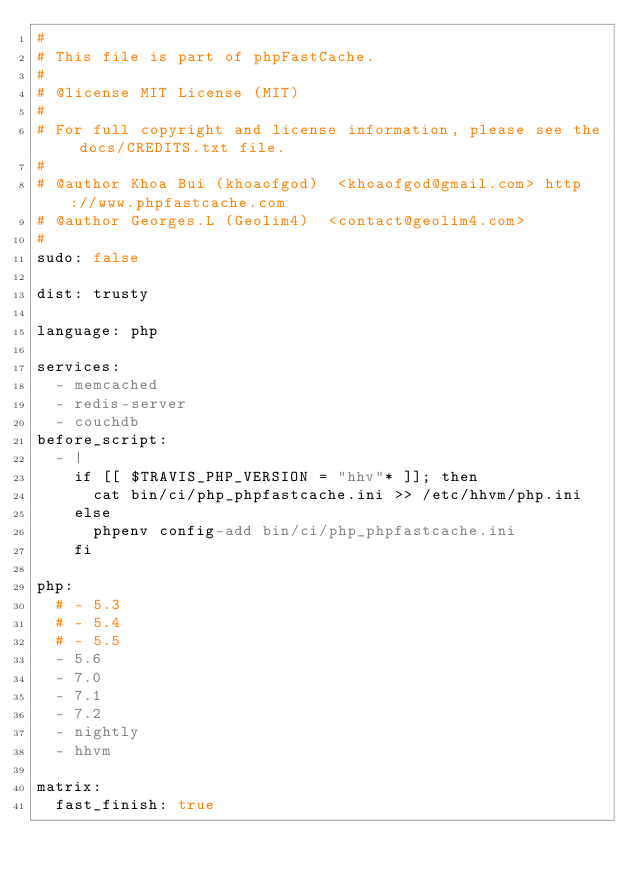Convert code to text. <code><loc_0><loc_0><loc_500><loc_500><_YAML_>#
# This file is part of phpFastCache.
#
# @license MIT License (MIT)
#
# For full copyright and license information, please see the docs/CREDITS.txt file.
#
# @author Khoa Bui (khoaofgod)  <khoaofgod@gmail.com> http://www.phpfastcache.com
# @author Georges.L (Geolim4)  <contact@geolim4.com>
#
sudo: false

dist: trusty

language: php

services:
  - memcached
  - redis-server
  - couchdb
before_script:
  - |
    if [[ $TRAVIS_PHP_VERSION = "hhv"* ]]; then
      cat bin/ci/php_phpfastcache.ini >> /etc/hhvm/php.ini
    else
      phpenv config-add bin/ci/php_phpfastcache.ini
    fi

php:
  # - 5.3
  # - 5.4
  # - 5.5
  - 5.6
  - 7.0
  - 7.1
  - 7.2
  - nightly
  - hhvm

matrix:
  fast_finish: true</code> 